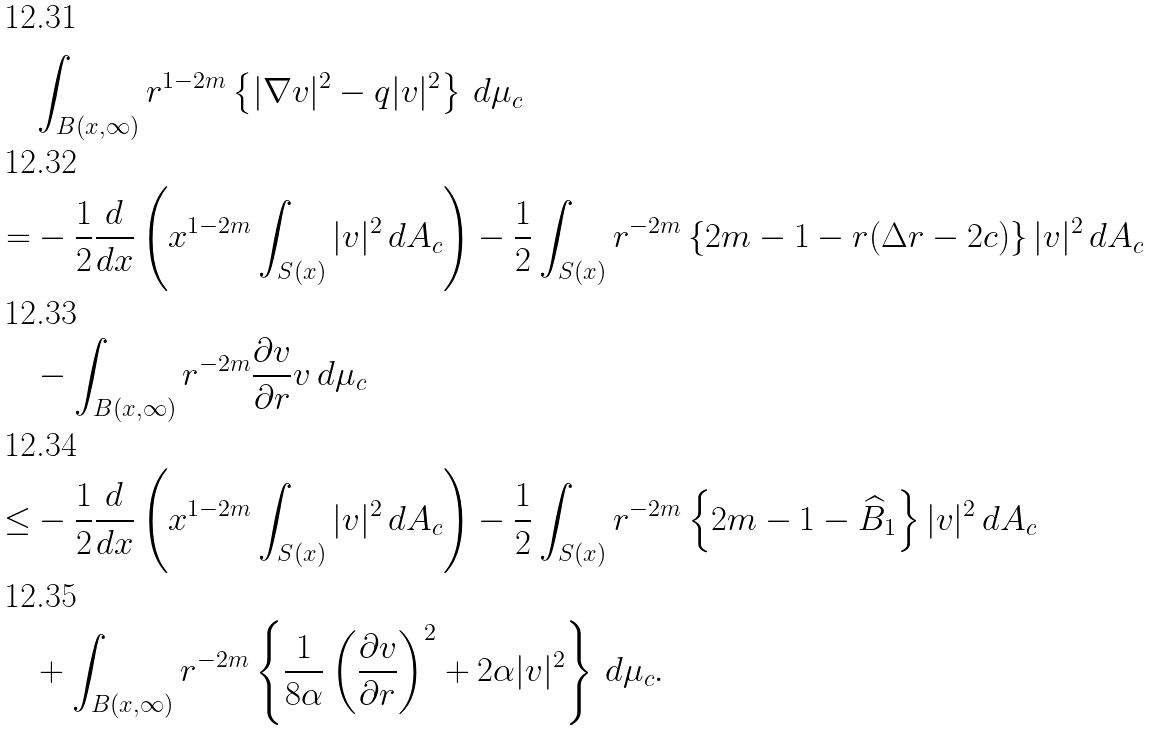<formula> <loc_0><loc_0><loc_500><loc_500>& \int _ { B ( x , \infty ) } r ^ { 1 - 2 m } \left \{ | \nabla v | ^ { 2 } - q | v | ^ { 2 } \right \} \, d \mu _ { c } \\ = & - \frac { 1 } { 2 } \frac { d } { d x } \left ( x ^ { 1 - 2 m } \int _ { S ( x ) } | v | ^ { 2 } \, d A _ { c } \right ) - \frac { 1 } { 2 } \int _ { S ( x ) } r ^ { - 2 m } \left \{ 2 m - 1 - r ( \Delta r - 2 c ) \right \} | v | ^ { 2 } \, d A _ { c } \\ & - \int _ { B ( x , \infty ) } r ^ { - 2 m } \frac { \partial v } { \partial r } v \, d \mu _ { c } \\ \leq & - \frac { 1 } { 2 } \frac { d } { d x } \left ( x ^ { 1 - 2 m } \int _ { S ( x ) } | v | ^ { 2 } \, d A _ { c } \right ) - \frac { 1 } { 2 } \int _ { S ( x ) } r ^ { - 2 m } \left \{ 2 m - 1 - \widehat { B } _ { 1 } \right \} | v | ^ { 2 } \, d A _ { c } \\ & + \int _ { B ( x , \infty ) } r ^ { - 2 m } \left \{ \frac { 1 } { 8 \alpha } \left ( \frac { \partial v } { \partial r } \right ) ^ { 2 } + 2 \alpha | v | ^ { 2 } \right \} \, d \mu _ { c } .</formula> 